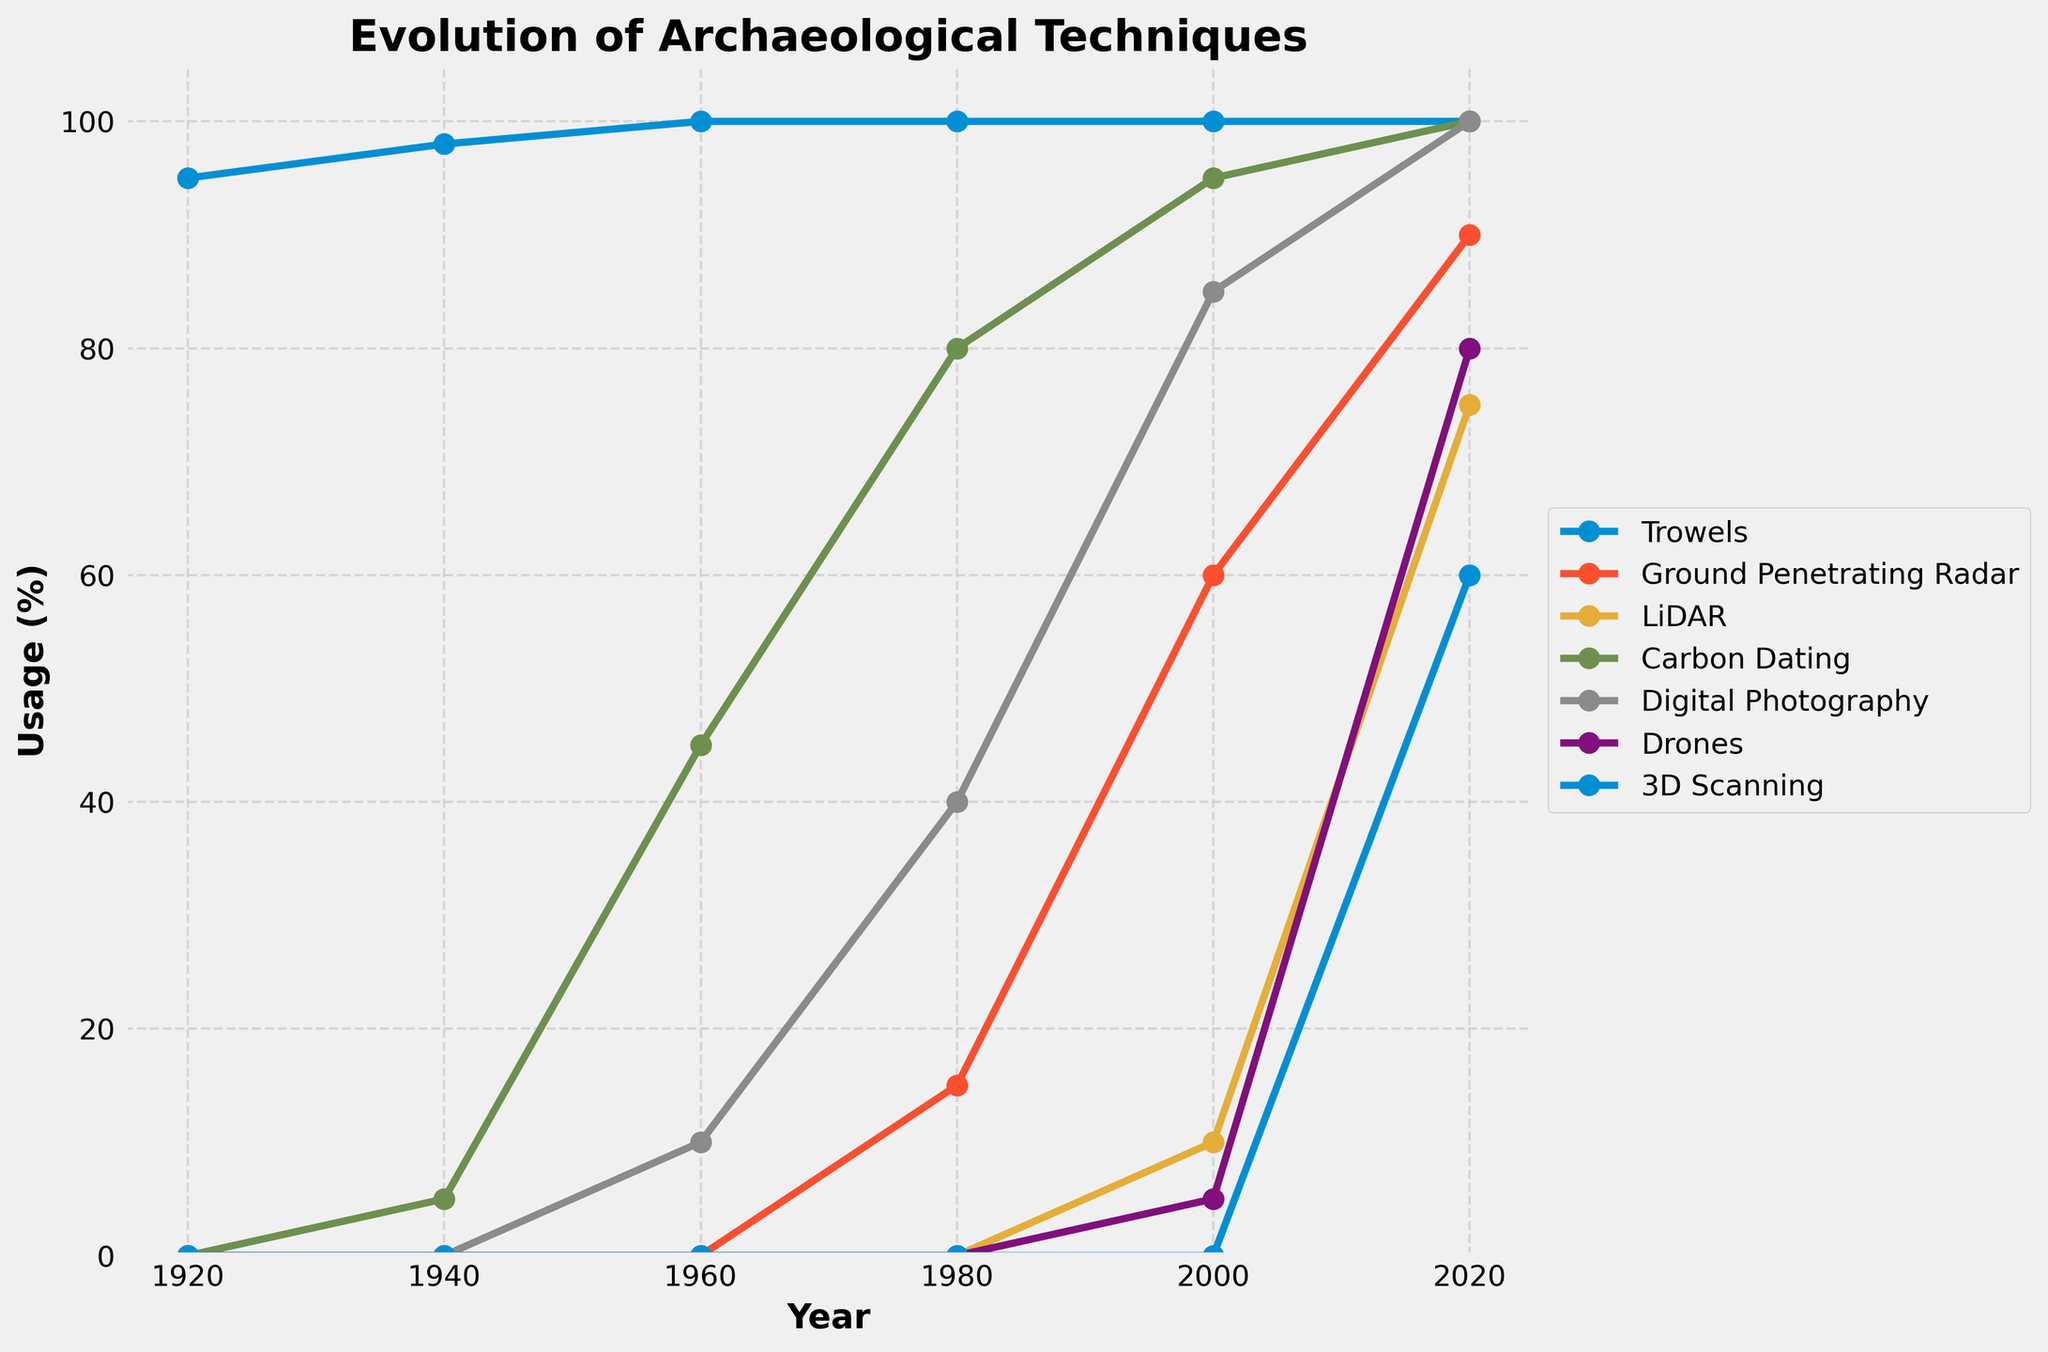How has the usage of trowels changed from 1920 to 2020? The figure shows that the usage of trowels has remained consistently high at or near 100% for each year from 1920 to 2020.
Answer: Stayed constant at 100% Which excavation technique saw the greatest increase in usage between 2000 and 2020? By comparing the usage percentages between 2000 and 2020 for all techniques, we see that LiDAR increased from 10% to 75%, which is a 65% increase, the highest of all.
Answer: LiDAR Compare the usage of Ground Penetrating Radar (GPR) and carbon dating in 1980. Which one was used more and by how much? The usage of Ground Penetrating Radar was 15% and carbon dating was 80% in 1980. Carbon dating was used more by (80-15) = 65%.
Answer: Carbon dating by 65% What is the average usage of drones in the years provided? The usage of drones across the years listed is: 0, 0, 0, 0, 5, 80. The average is calculated as (0 + 0 + 0 + 0 + 5 + 80) / 6 = 85 / 6 ≈ 14.17%.
Answer: Approximately 14.17% In which year did digital photography first appear, and what was its usage percentage? The figure shows that digital photography first appeared in 1960 with a 10% usage.
Answer: 1960, 10% What percentage increase in the use of 3D scanning technology occurred from 2000 to 2020? The usage of 3D scanning was 0% in 2000 and increased to 60% in 2020. The percentage increase is ((60 - 0) / 0) = infinite percentage since it was not used previously and now is in use.
Answer: 60% Which tool or technique had the smallest increase in usage from 1940 to 1960? By comparing the usage in 1940 and 1960, trowels (from 98 to 100), Ground Penetrating Radar (0 to 0), LiDAR (0 to 0), carbon dating (5 to 45), digital photography (0 to 10), drones (0 to 0), 3D scanning (0 to 0). GPR and LiDAR had no increase, so the smallest increase is 0%.
Answer: Ground Penetrating Radar and LiDAR (0%) What’s the sum of the percentage usages of all techniques in 2020? Adding the percentage usages of all tools in 2020: 100 (Trowels) + 90 (GPR) + 75 (LiDAR) + 100 (Carbon Dating) + 100 (Digital Photography) + 80 (Drones) + 60 (3D Scanning) = 605%
Answer: 605% Which technique had the quickest adoption rate from its first appearance to full usage (100%)? Carbon Dating first appeared with 5% usage in 1940 and reached 100% by 2020, a span of 80 years. Digital photography first appeared in 1960 with 10% and reached 100% by 2020, a span of 60 years. Therefore, Digital photography had the quickest adoption rate.
Answer: Digital Photography Between which consecutive decades did drones see the most significant increase in usage? Comparing the consecutive decades: 1920-1940 (0% increase), 1940-1960 (0% increase), 1960-1980 (0% increase), 1980-2000 (0 to 5 = 5% increase), 2000-2020 (5 to 80 = 75% increase). So the greatest increase is from 2000 to 2020 with 75%.
Answer: Between 2000 and 2020 